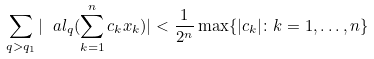<formula> <loc_0><loc_0><loc_500><loc_500>\sum _ { q > q _ { 1 } } | \ a l _ { q } ( \sum _ { k = 1 } ^ { n } c _ { k } x _ { k } ) | < \frac { 1 } { 2 ^ { n } } \max \{ | c _ { k } | \colon k = 1 , \dots , n \}</formula> 